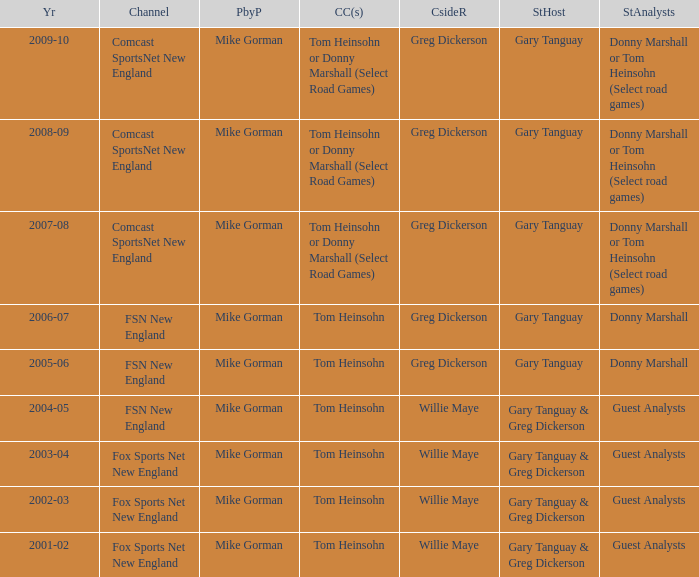Who is the courtside reporter for the year 2009-10? Greg Dickerson. 